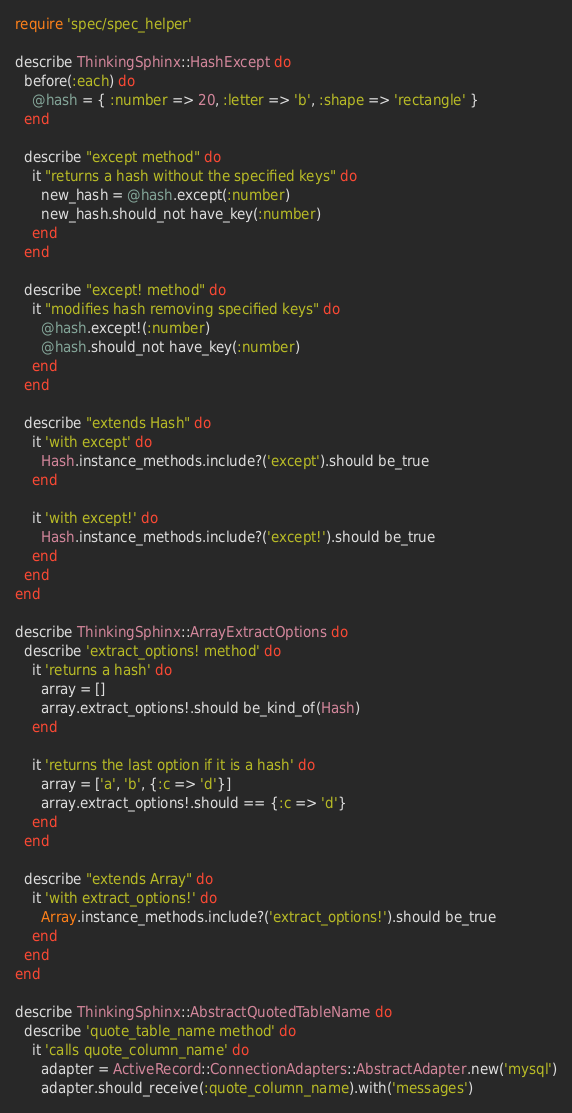Convert code to text. <code><loc_0><loc_0><loc_500><loc_500><_Ruby_>require 'spec/spec_helper'

describe ThinkingSphinx::HashExcept do
  before(:each) do
    @hash = { :number => 20, :letter => 'b', :shape => 'rectangle' }
  end
  
  describe "except method" do
    it "returns a hash without the specified keys" do
      new_hash = @hash.except(:number)
      new_hash.should_not have_key(:number)
    end
  end
  
  describe "except! method" do
    it "modifies hash removing specified keys" do
      @hash.except!(:number)
      @hash.should_not have_key(:number)
    end
  end
  
  describe "extends Hash" do
    it 'with except' do
      Hash.instance_methods.include?('except').should be_true
    end

    it 'with except!' do
      Hash.instance_methods.include?('except!').should be_true
    end
  end
end

describe ThinkingSphinx::ArrayExtractOptions do
  describe 'extract_options! method' do
    it 'returns a hash' do
      array = []
      array.extract_options!.should be_kind_of(Hash)
    end

    it 'returns the last option if it is a hash' do
      array = ['a', 'b', {:c => 'd'}]
      array.extract_options!.should == {:c => 'd'}
    end
  end
  
  describe "extends Array" do
    it 'with extract_options!' do
      Array.instance_methods.include?('extract_options!').should be_true
    end
  end
end

describe ThinkingSphinx::AbstractQuotedTableName do
  describe 'quote_table_name method' do
    it 'calls quote_column_name' do
      adapter = ActiveRecord::ConnectionAdapters::AbstractAdapter.new('mysql')
      adapter.should_receive(:quote_column_name).with('messages')</code> 